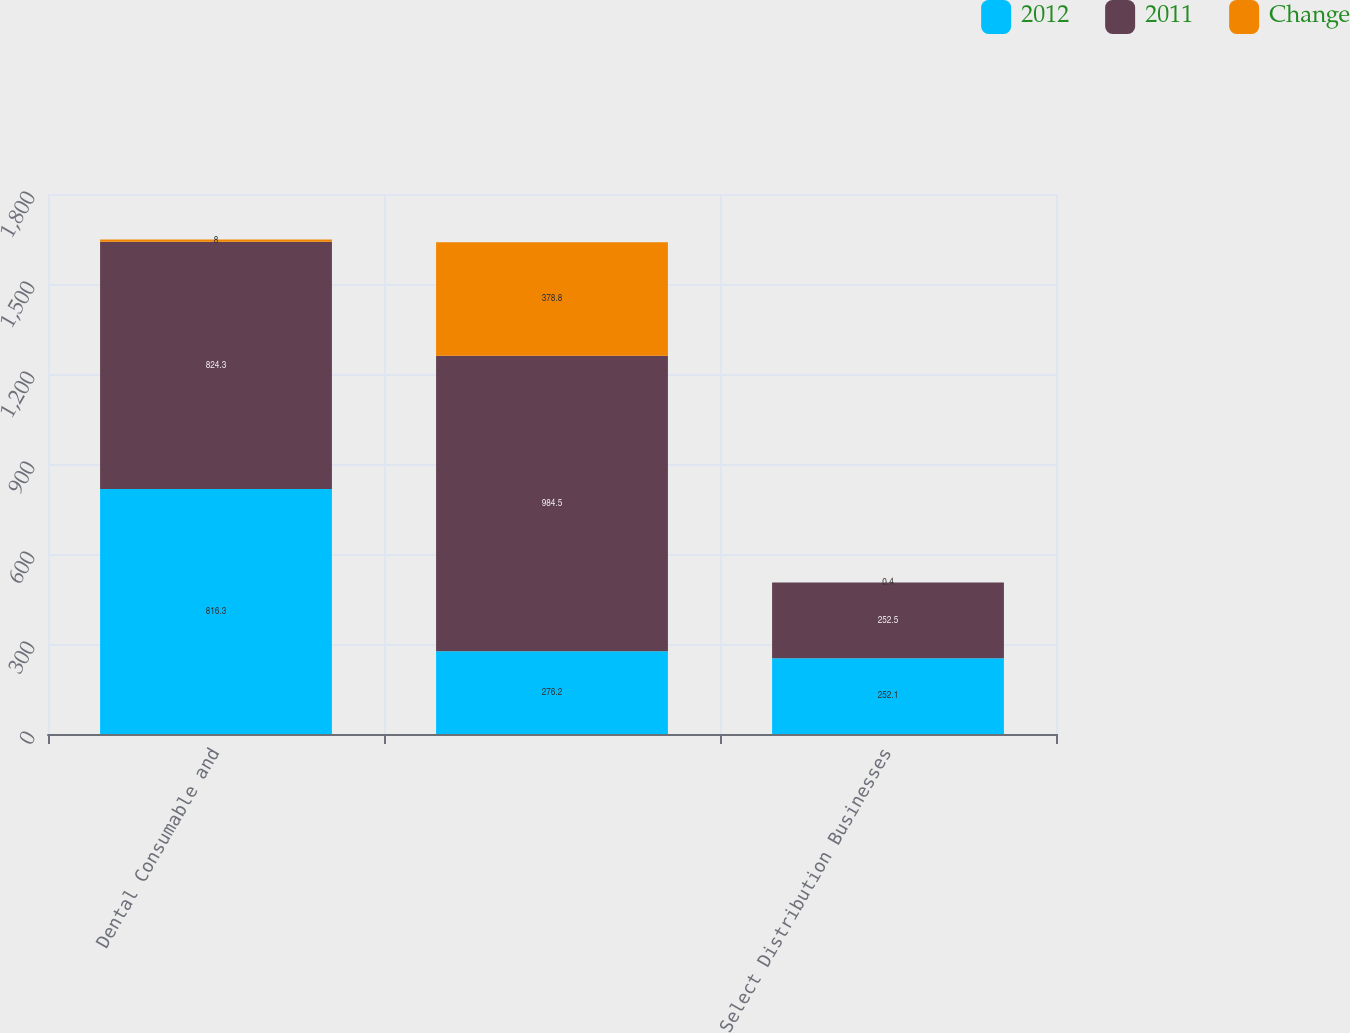Convert chart to OTSL. <chart><loc_0><loc_0><loc_500><loc_500><stacked_bar_chart><ecel><fcel>Dental Consumable and<fcel>Unnamed: 2<fcel>Select Distribution Businesses<nl><fcel>2012<fcel>816.3<fcel>276.2<fcel>252.1<nl><fcel>2011<fcel>824.3<fcel>984.5<fcel>252.5<nl><fcel>Change<fcel>8<fcel>378.8<fcel>0.4<nl></chart> 